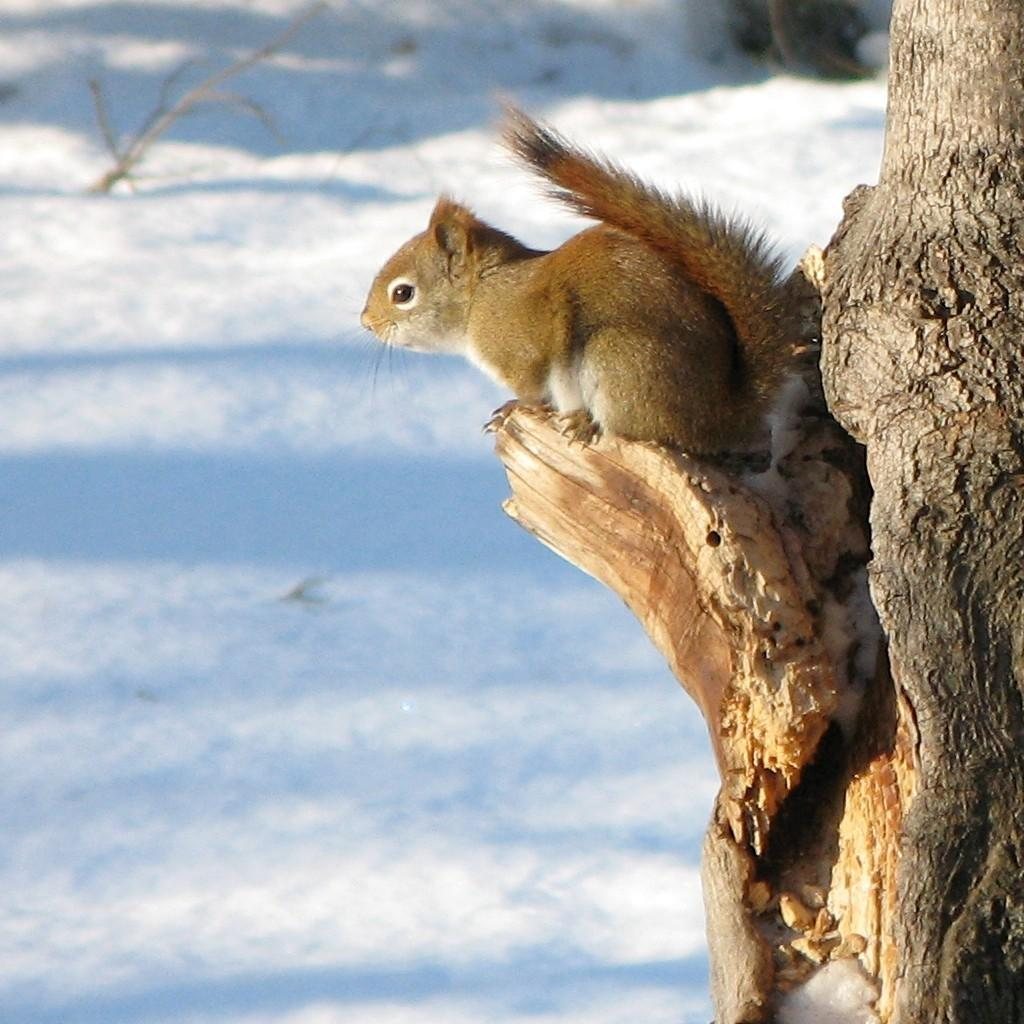What animal is present in the image? There is a squirrel in the image. Where is the squirrel located? The squirrel is on a tree. What is the color of the squirrel? The squirrel is brown in color. What can be seen in the background of the image? There is snow visible in the background of the image. What type of net can be seen in the image? There is no net present in the image; it features a squirrel on a tree with snow in the background. 